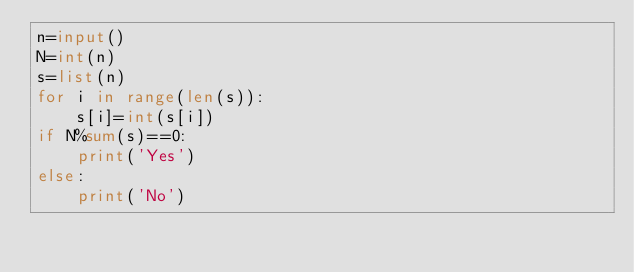<code> <loc_0><loc_0><loc_500><loc_500><_Python_>n=input()
N=int(n)
s=list(n)
for i in range(len(s)):
    s[i]=int(s[i])
if N%sum(s)==0:
    print('Yes')
else:
    print('No')</code> 